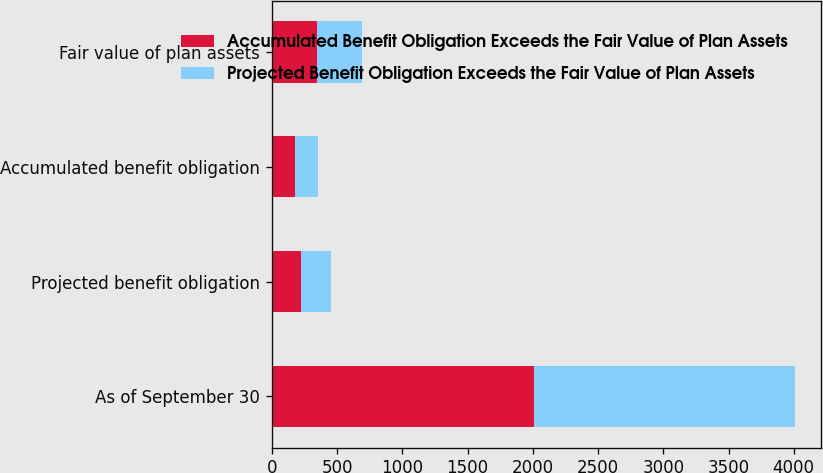Convert chart. <chart><loc_0><loc_0><loc_500><loc_500><stacked_bar_chart><ecel><fcel>As of September 30<fcel>Projected benefit obligation<fcel>Accumulated benefit obligation<fcel>Fair value of plan assets<nl><fcel>Accumulated Benefit Obligation Exceeds the Fair Value of Plan Assets<fcel>2006<fcel>227<fcel>176<fcel>347<nl><fcel>Projected Benefit Obligation Exceeds the Fair Value of Plan Assets<fcel>2006<fcel>227<fcel>176<fcel>342<nl></chart> 